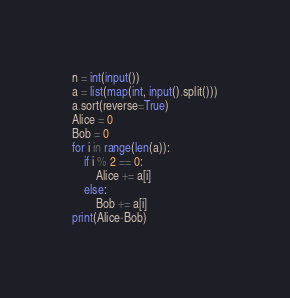<code> <loc_0><loc_0><loc_500><loc_500><_Python_>n = int(input())
a = list(map(int, input().split()))
a.sort(reverse=True)
Alice = 0
Bob = 0
for i in range(len(a)):
    if i % 2 == 0:
        Alice += a[i]
    else:
        Bob += a[i]
print(Alice-Bob)</code> 